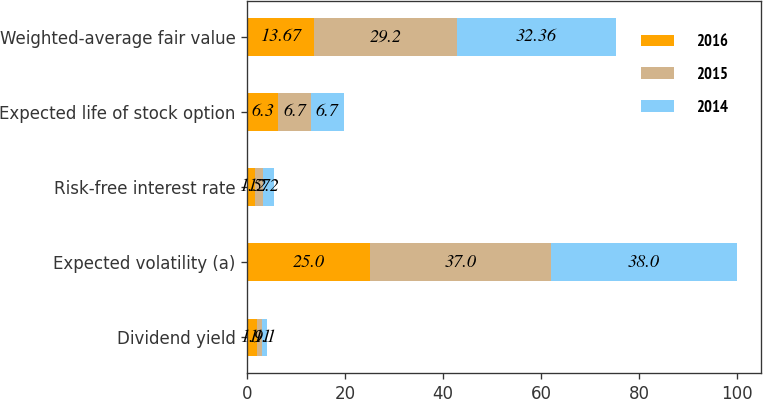<chart> <loc_0><loc_0><loc_500><loc_500><stacked_bar_chart><ecel><fcel>Dividend yield<fcel>Expected volatility (a)<fcel>Risk-free interest rate<fcel>Expected life of stock option<fcel>Weighted-average fair value<nl><fcel>2016<fcel>1.9<fcel>25<fcel>1.5<fcel>6.3<fcel>13.67<nl><fcel>2015<fcel>1.1<fcel>37<fcel>1.7<fcel>6.7<fcel>29.2<nl><fcel>2014<fcel>1.1<fcel>38<fcel>2.2<fcel>6.7<fcel>32.36<nl></chart> 